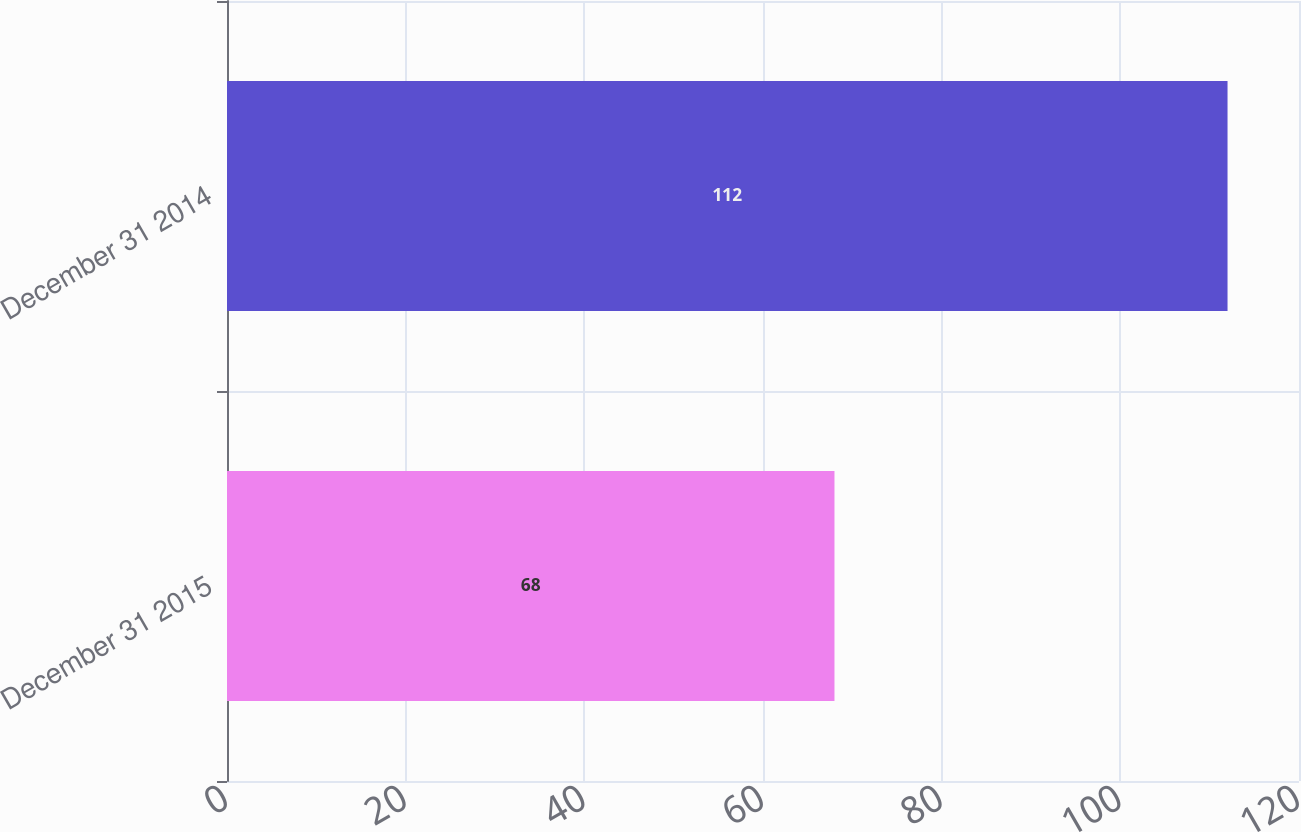<chart> <loc_0><loc_0><loc_500><loc_500><bar_chart><fcel>December 31 2015<fcel>December 31 2014<nl><fcel>68<fcel>112<nl></chart> 